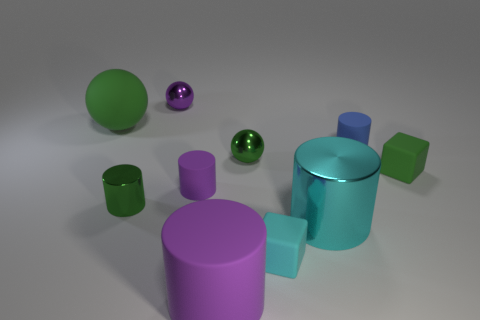Can you describe the shapes and colors of the objects in the image? Certainly! The image features a collection of geometric shapes including cylinders, cubes, and spheres. The colors present are green, purple, and teal. There's a green cube and sphere, a purple cylinder and cube, and a teal cylinder and sphere. Do any of these objects share both shape and color? Yes, there are two objects sharing both shape and color: the green sphere and the teal cylinder. 